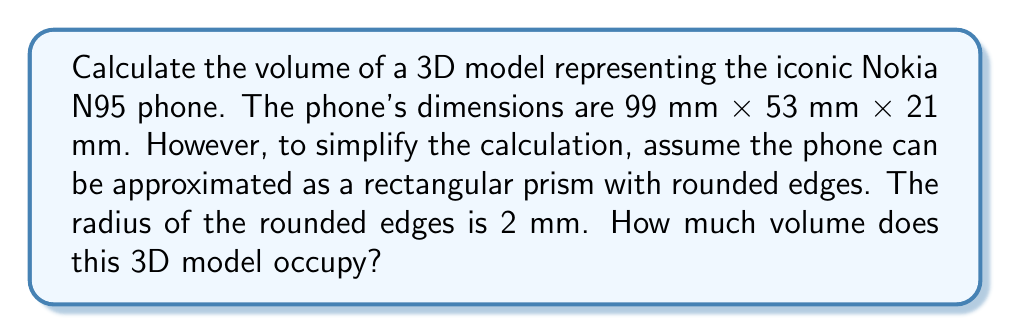Could you help me with this problem? Let's approach this step-by-step:

1) First, we need to calculate the volume of a rectangular prism with the given dimensions:
   $$V_{prism} = l \times w \times h = 99 \times 53 \times 21 = 110,187 \text{ mm}^3$$

2) Next, we need to account for the rounded edges. There are 12 edges on a rectangular prism, each with a length equal to one of the dimensions. The volume we need to subtract for each edge is the difference between a square corner and a rounded corner, which is a cylinder with radius 2 mm.

3) The volume of this cylindrical edge segment is:
   $$V_{edge} = \pi r^2 l$$
   Where $r$ is the radius of the rounded edge (2 mm) and $l$ is the length of the edge.

4) We have:
   - 4 edges of length 99 mm
   - 4 edges of length 53 mm
   - 4 edges of length 21 mm

5) So the total volume to subtract is:
   $$V_{subtract} = 4\pi r^2(99 + 53 + 21) = 4\pi(2^2)(173) = 8,690.27 \text{ mm}^3$$

6) Therefore, the final volume is:
   $$V_{final} = V_{prism} - V_{subtract} = 110,187 - 8,690.27 = 101,496.73 \text{ mm}^3$$

7) Rounding to the nearest whole number:
   $$V_{final} \approx 101,497 \text{ mm}^3$$
Answer: 101,497 mm³ 